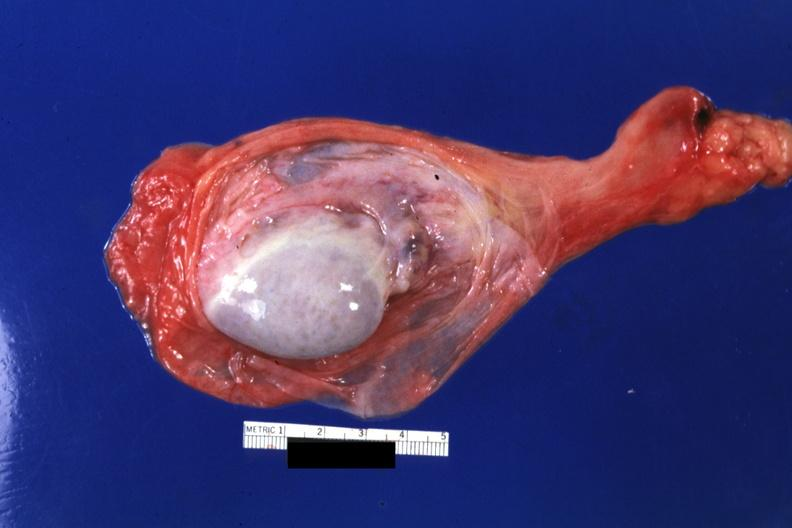does this image show sac opened?
Answer the question using a single word or phrase. Yes 